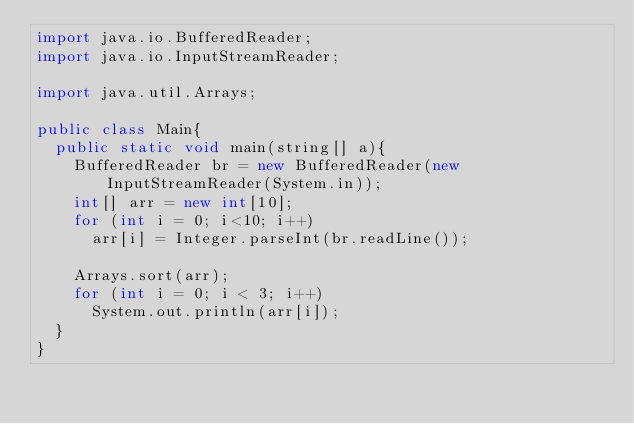Convert code to text. <code><loc_0><loc_0><loc_500><loc_500><_Java_>import java.io.BufferedReader;
import java.io.InputStreamReader;

import java.util.Arrays;

public class Main{
  public static void main(string[] a){
    BufferedReader br = new BufferedReader(new InputStreamReader(System.in));
    int[] arr = new int[10]; 
    for (int i = 0; i<10; i++)
      arr[i] = Integer.parseInt(br.readLine());

    Arrays.sort(arr);
    for (int i = 0; i < 3; i++)
      System.out.println(arr[i]);
  }
}</code> 